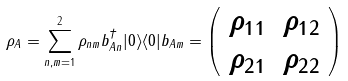<formula> <loc_0><loc_0><loc_500><loc_500>\rho _ { A } = \sum _ { n , m = 1 } ^ { 2 } \rho _ { n m } b _ { A n } ^ { \dagger } | 0 \rangle \langle 0 | b _ { A m } = \left ( \begin{array} { c c } \rho _ { 1 1 } & \rho _ { 1 2 } \\ \rho _ { 2 1 } & \rho _ { 2 2 } \end{array} \right )</formula> 